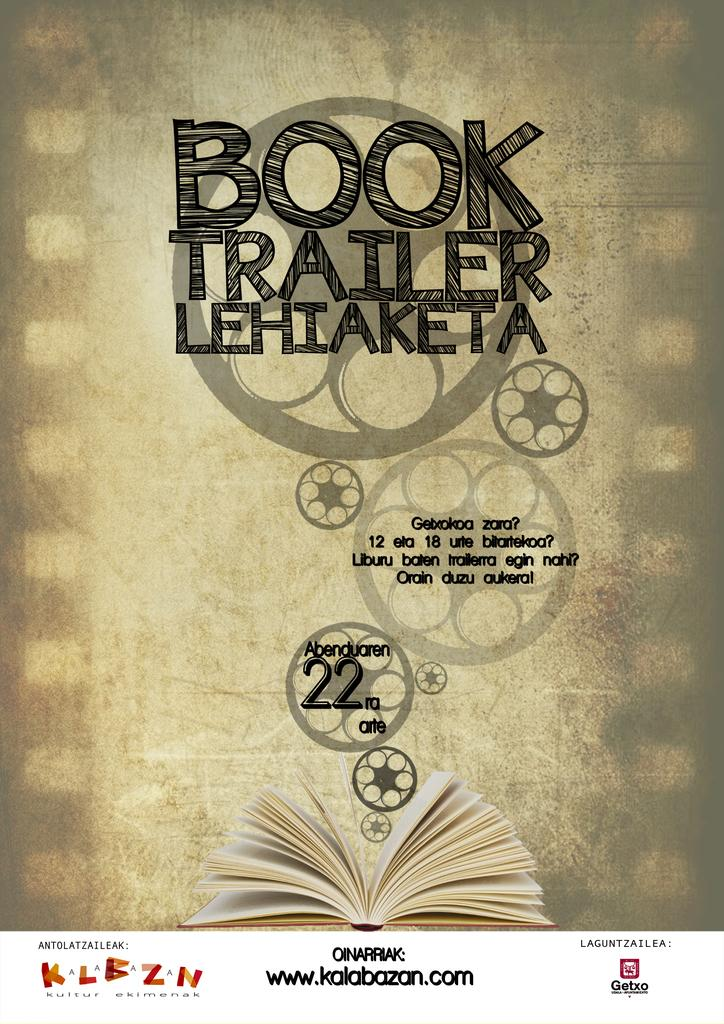<image>
Give a short and clear explanation of the subsequent image. Book trailer Lehiaketa Abenduaren that consists of chapters 